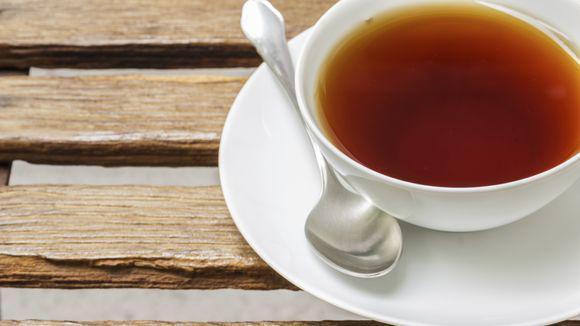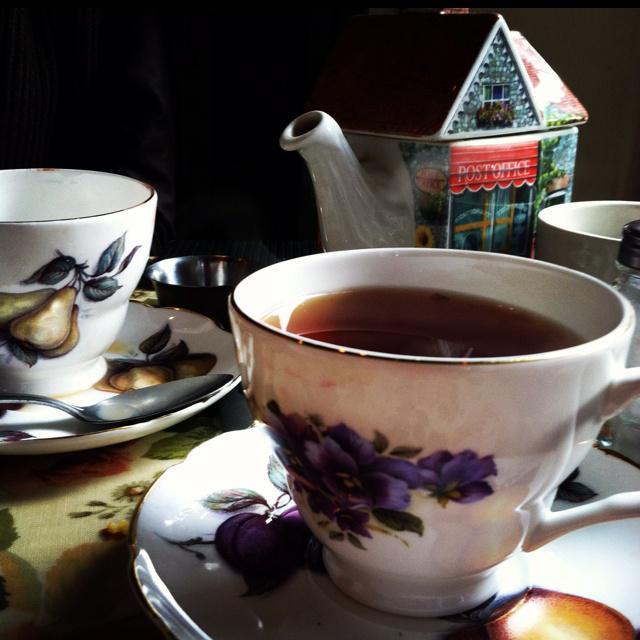The first image is the image on the left, the second image is the image on the right. For the images shown, is this caption "The right image includes a porcelain cup with flowers on it sitting on a saucer in front of a container with a spout." true? Answer yes or no. Yes. The first image is the image on the left, the second image is the image on the right. Examine the images to the left and right. Is the description "Any cups in the left image are solid white and any cups in the right image are not solid white." accurate? Answer yes or no. Yes. 